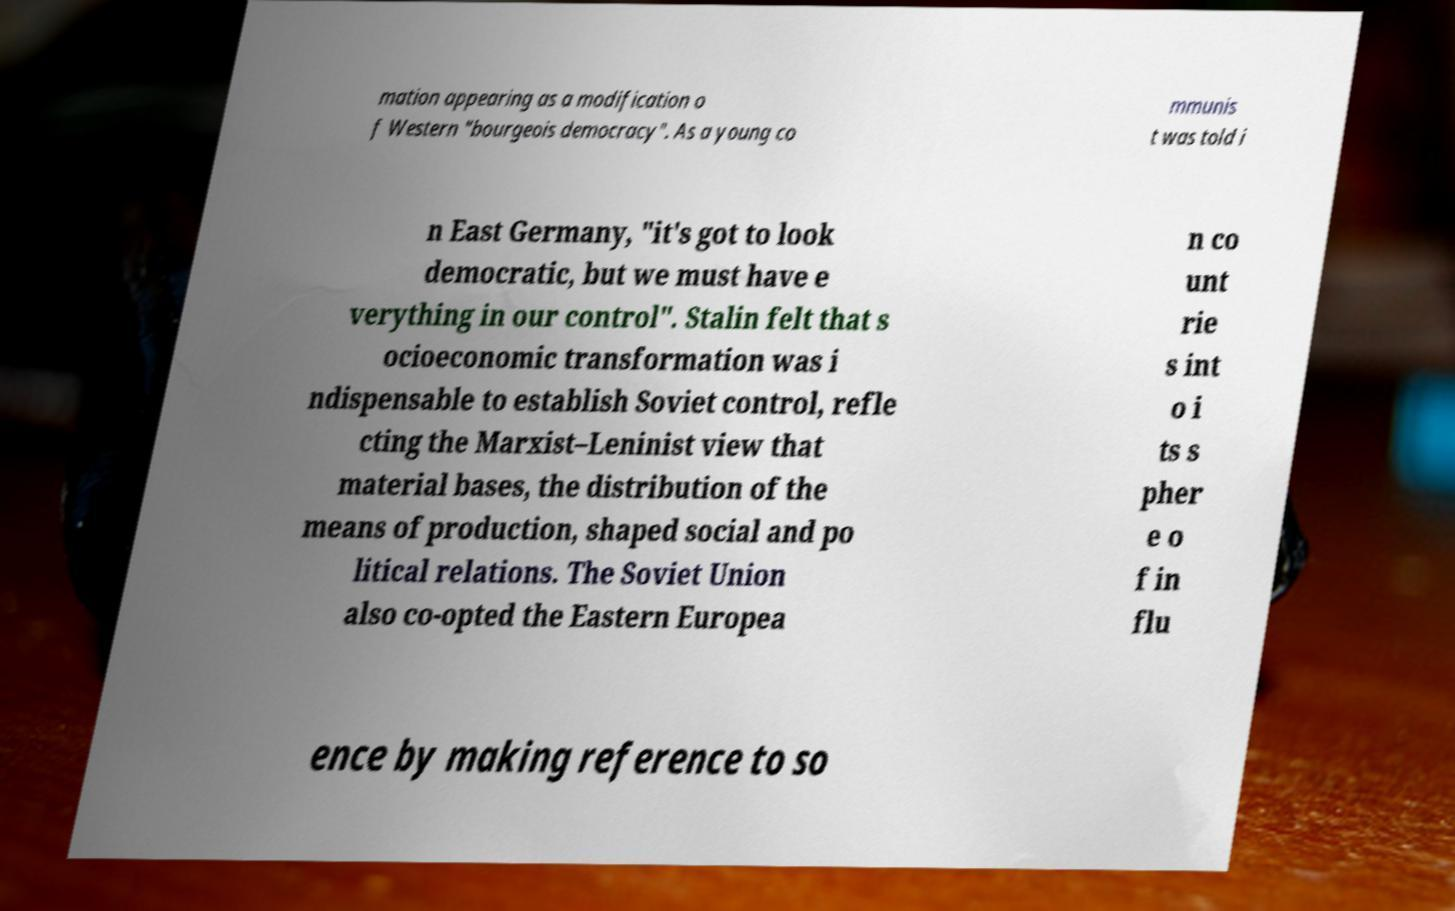Can you read and provide the text displayed in the image?This photo seems to have some interesting text. Can you extract and type it out for me? mation appearing as a modification o f Western "bourgeois democracy". As a young co mmunis t was told i n East Germany, "it's got to look democratic, but we must have e verything in our control". Stalin felt that s ocioeconomic transformation was i ndispensable to establish Soviet control, refle cting the Marxist–Leninist view that material bases, the distribution of the means of production, shaped social and po litical relations. The Soviet Union also co-opted the Eastern Europea n co unt rie s int o i ts s pher e o f in flu ence by making reference to so 